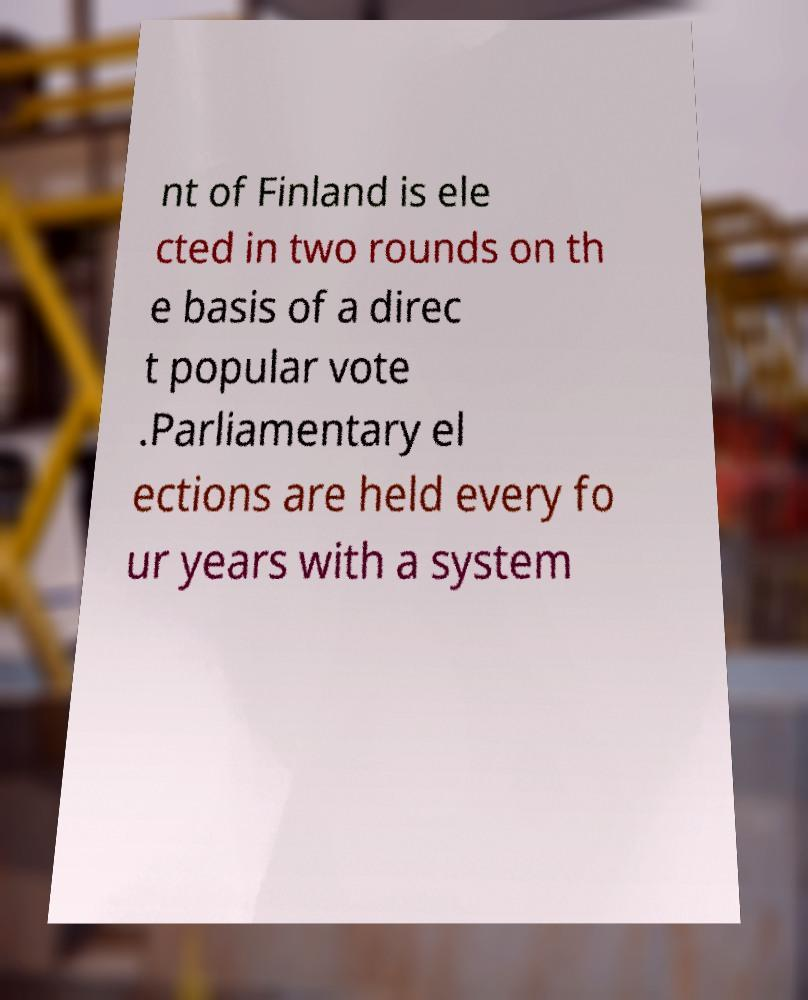Could you assist in decoding the text presented in this image and type it out clearly? nt of Finland is ele cted in two rounds on th e basis of a direc t popular vote .Parliamentary el ections are held every fo ur years with a system 